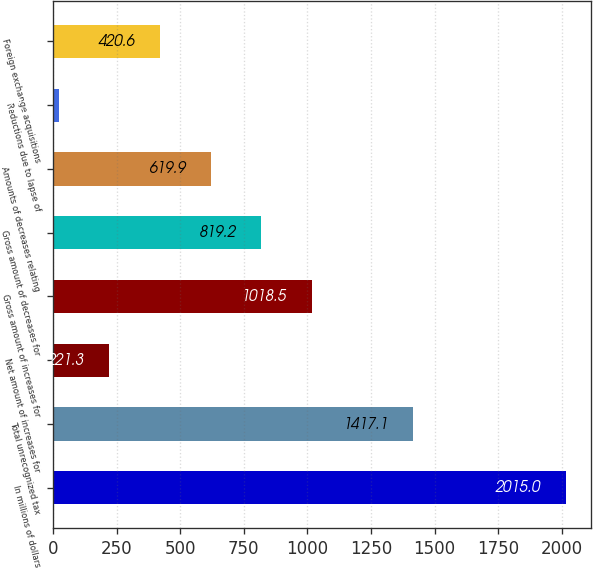<chart> <loc_0><loc_0><loc_500><loc_500><bar_chart><fcel>In millions of dollars<fcel>Total unrecognized tax<fcel>Net amount of increases for<fcel>Gross amount of increases for<fcel>Gross amount of decreases for<fcel>Amounts of decreases relating<fcel>Reductions due to lapse of<fcel>Foreign exchange acquisitions<nl><fcel>2015<fcel>1417.1<fcel>221.3<fcel>1018.5<fcel>819.2<fcel>619.9<fcel>22<fcel>420.6<nl></chart> 